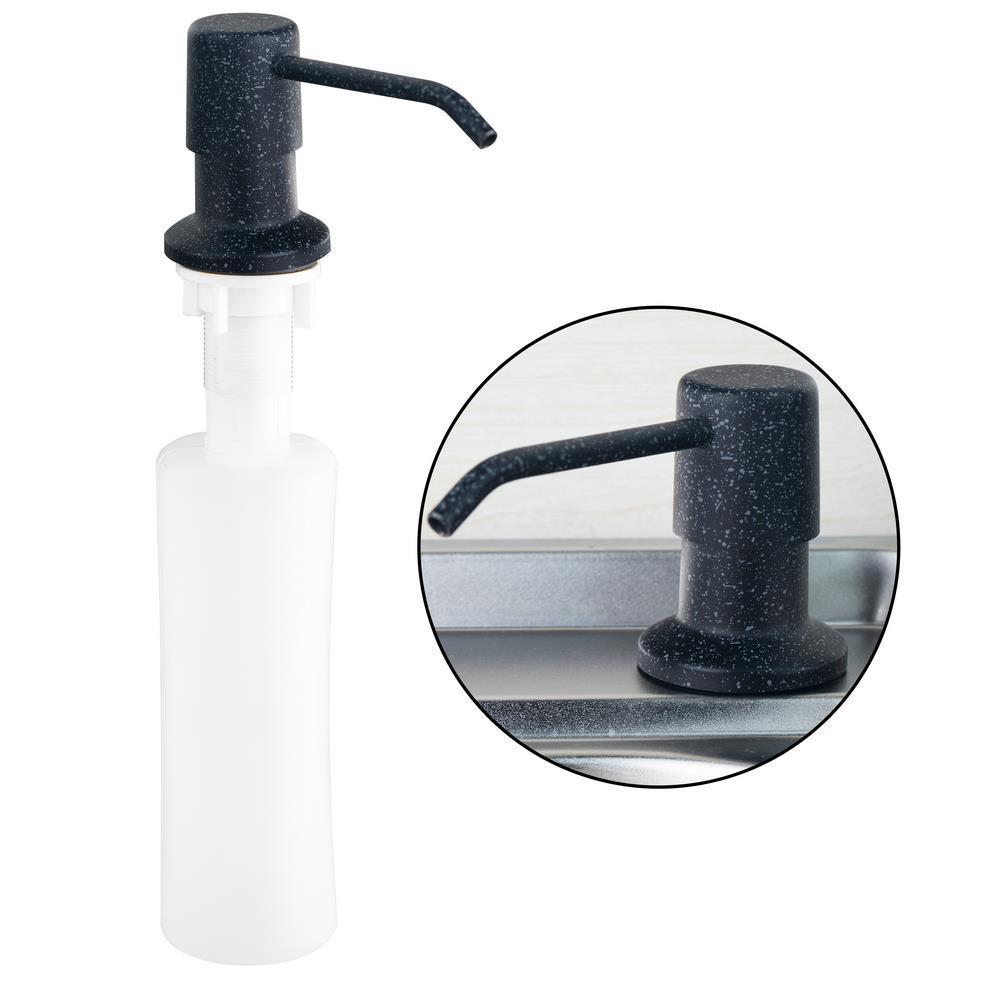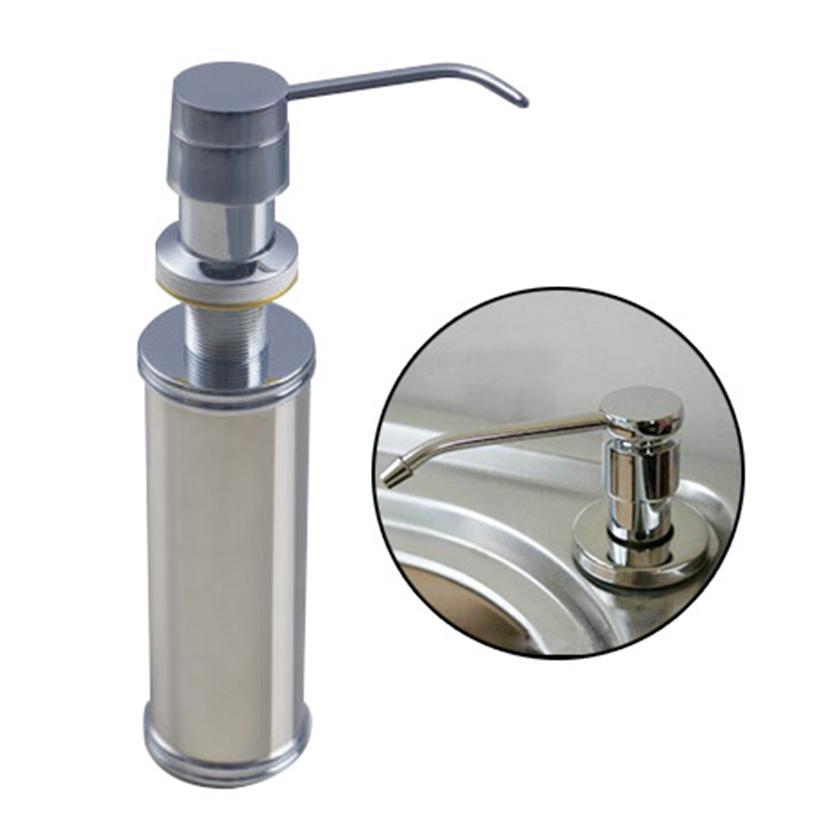The first image is the image on the left, the second image is the image on the right. Given the left and right images, does the statement "The pump spigots are all facing to the left." hold true? Answer yes or no. No. 